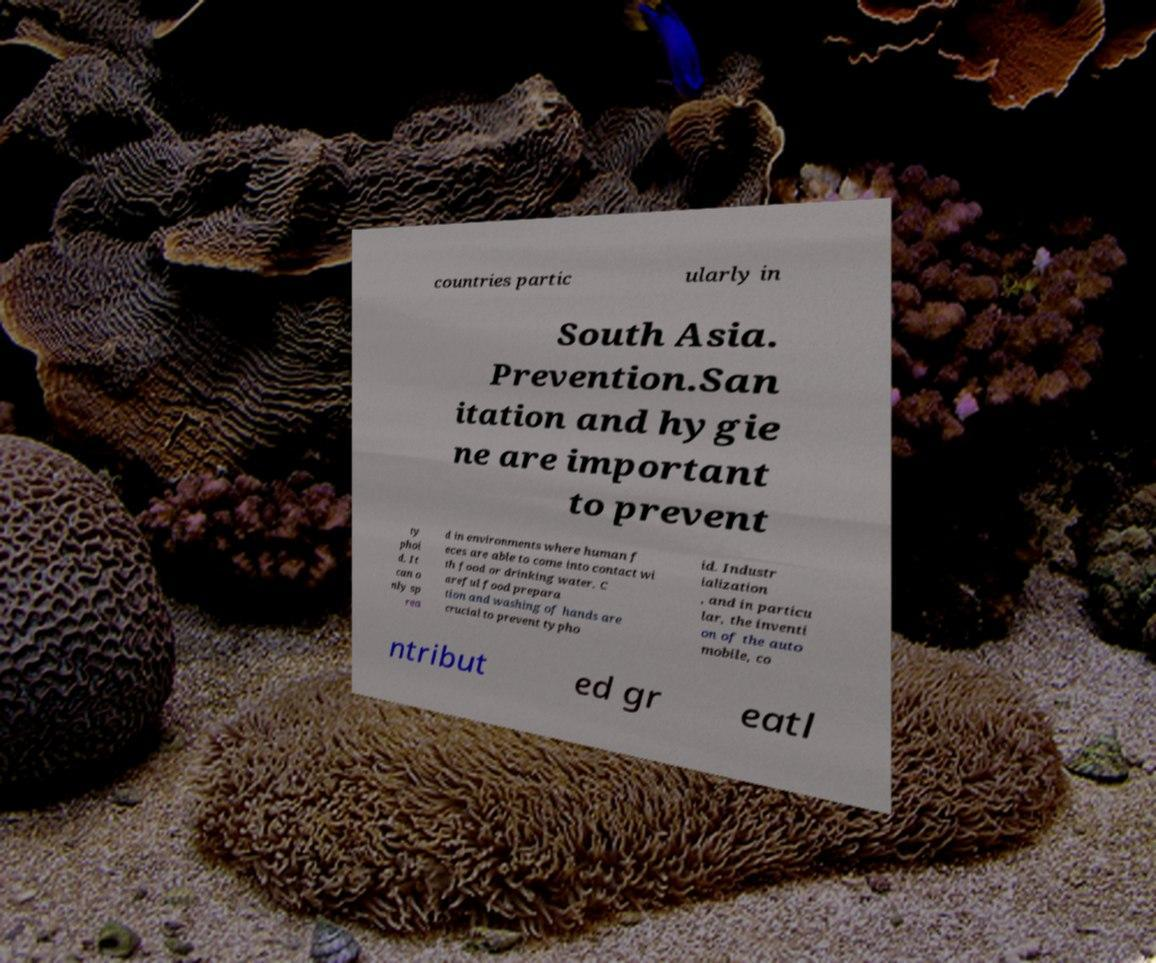Can you accurately transcribe the text from the provided image for me? countries partic ularly in South Asia. Prevention.San itation and hygie ne are important to prevent ty phoi d. It can o nly sp rea d in environments where human f eces are able to come into contact wi th food or drinking water. C areful food prepara tion and washing of hands are crucial to prevent typho id. Industr ialization , and in particu lar, the inventi on of the auto mobile, co ntribut ed gr eatl 